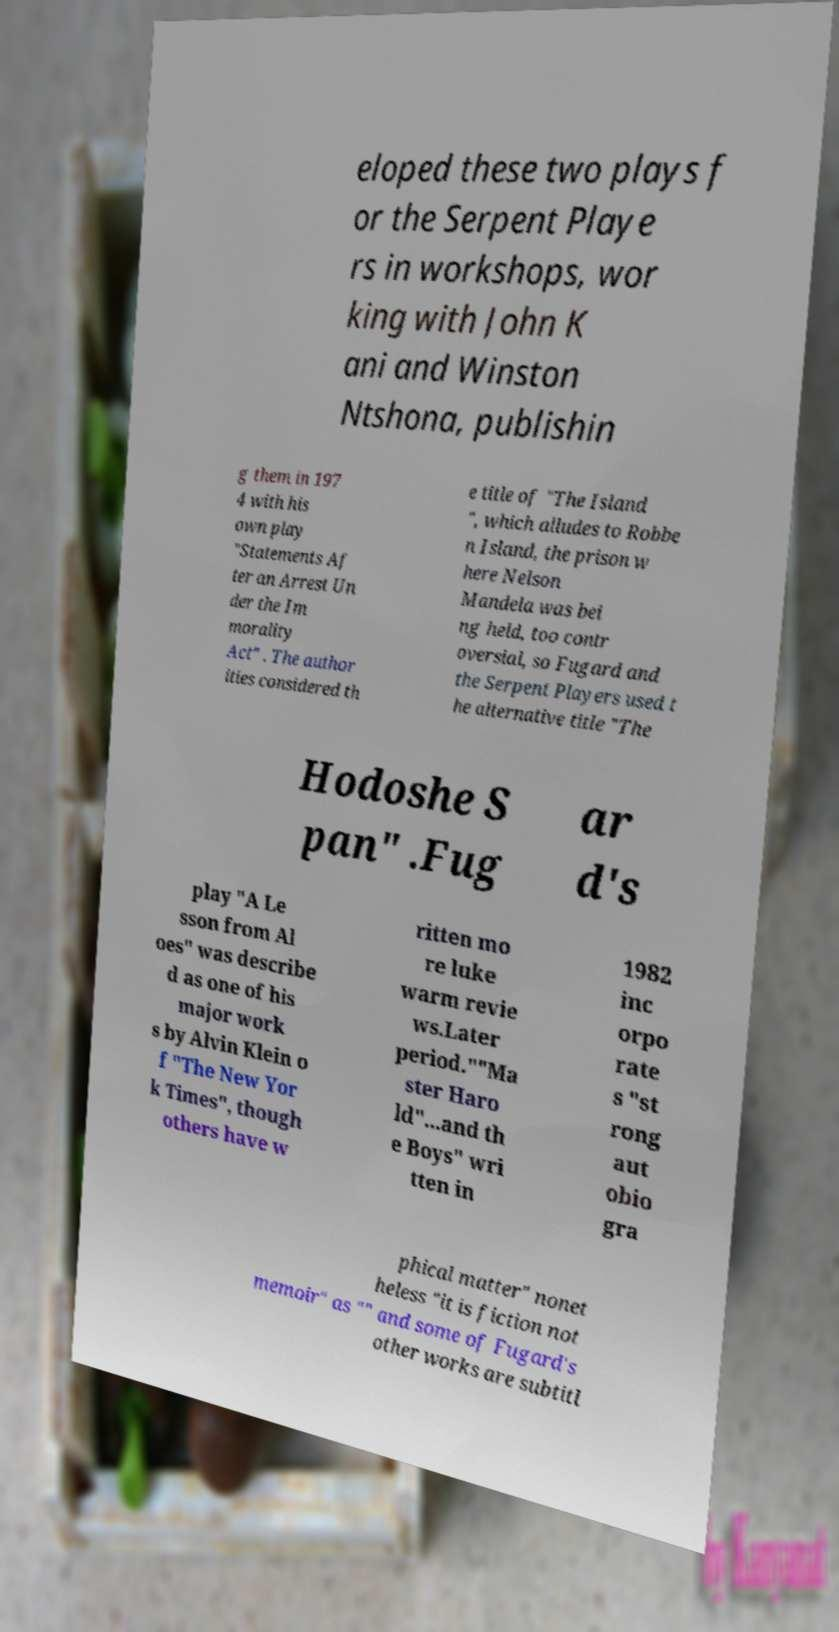Can you read and provide the text displayed in the image?This photo seems to have some interesting text. Can you extract and type it out for me? eloped these two plays f or the Serpent Playe rs in workshops, wor king with John K ani and Winston Ntshona, publishin g them in 197 4 with his own play "Statements Af ter an Arrest Un der the Im morality Act" . The author ities considered th e title of "The Island ", which alludes to Robbe n Island, the prison w here Nelson Mandela was bei ng held, too contr oversial, so Fugard and the Serpent Players used t he alternative title "The Hodoshe S pan" .Fug ar d's play "A Le sson from Al oes" was describe d as one of his major work s by Alvin Klein o f "The New Yor k Times", though others have w ritten mo re luke warm revie ws.Later period.""Ma ster Haro ld"...and th e Boys" wri tten in 1982 inc orpo rate s "st rong aut obio gra phical matter" nonet heless "it is fiction not memoir" as "" and some of Fugard's other works are subtitl 